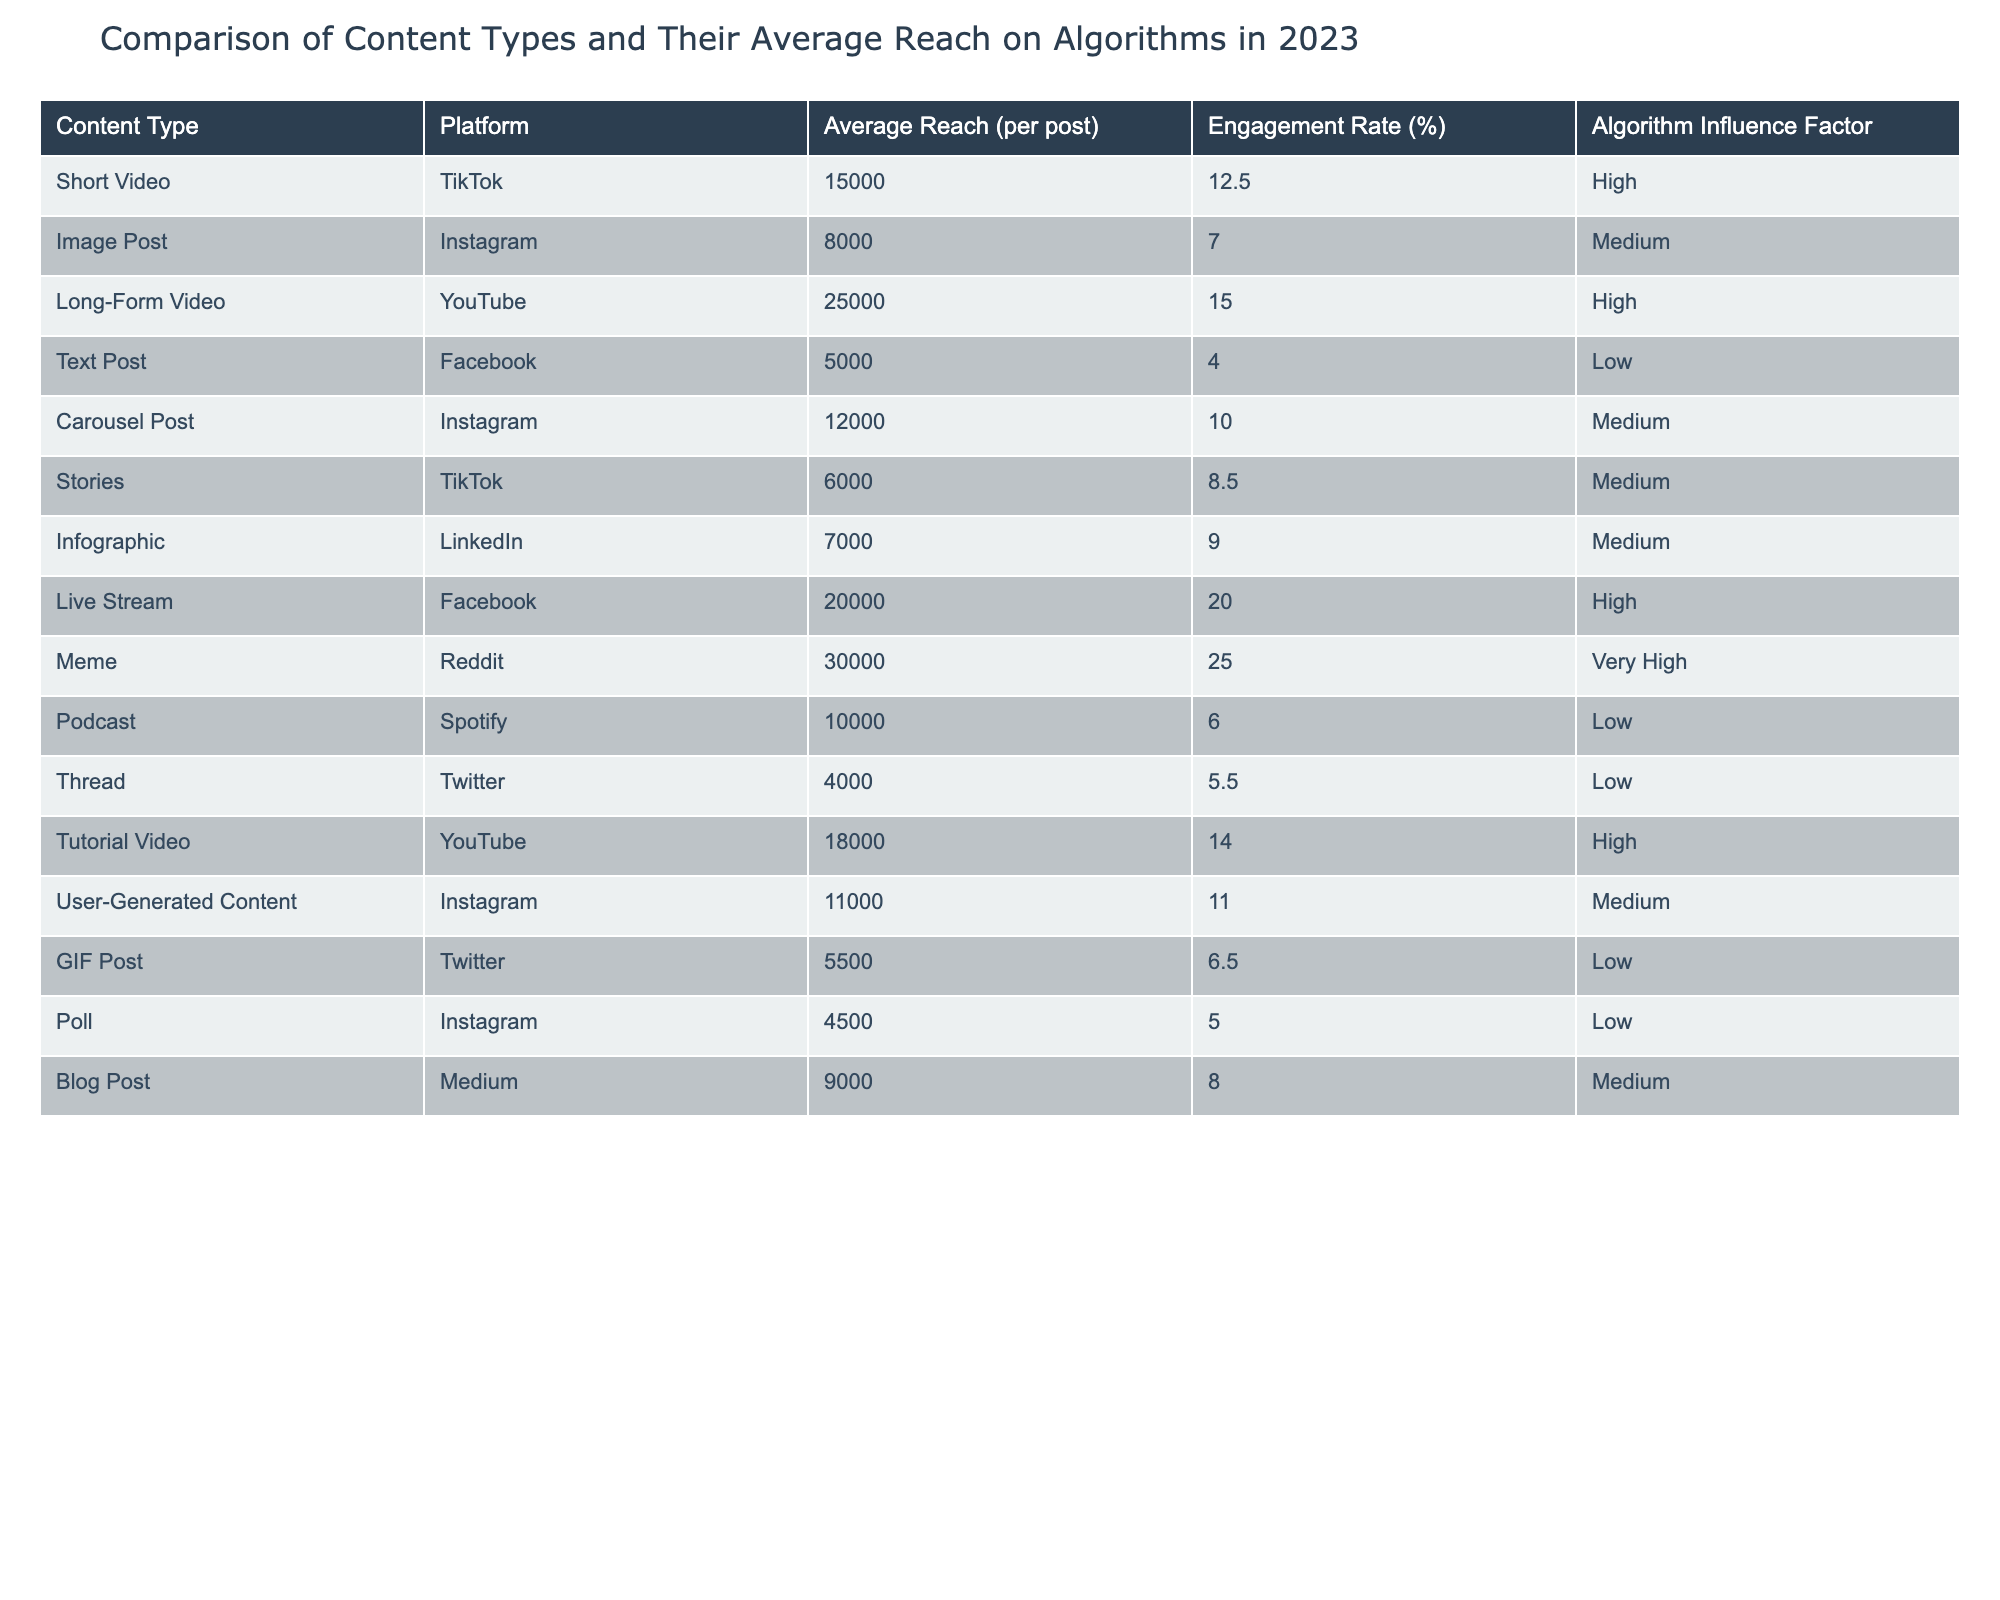What is the average reach for Long-Form Video on YouTube? The table indicates that the average reach for Long-Form Video on YouTube is 25000 per post.
Answer: 25000 Which content type has the highest engagement rate and what is that rate? In the table, the content type that has the highest engagement rate is Meme on Reddit, which has an engagement rate of 25.0%.
Answer: 25.0% How many content types have a 'Low' algorithm influence factor? By examining the table, there are four content types with a 'Low' algorithm influence factor: Text Post, Podcast, Thread, and GIF Post.
Answer: 4 What is the difference in average reach between Carousel Post and Stories on TikTok? The average reach for Carousel Post is 12000 and for Stories, it is 6000. The difference is 12000 - 6000 = 6000.
Answer: 6000 Is the average reach for Image Posts higher than for Infographics? The average reach for Image Posts is 8000 while for Infographics it is 7000. Since 8000 is greater than 7000, the statement is true.
Answer: Yes What is the combined average reach of User-Generated Content and Carousel Post? The average reach for User-Generated Content is 11000 and for Carousel Post is 12000. Adding these together gives 11000 + 12000 = 23000.
Answer: 23000 Which content type has the lowest engagement rate and what is that rate? The table shows that Text Post on Facebook has the lowest engagement rate at 4.0%.
Answer: 4.0% If you add the average reaches of the top three content types, what is the total? The top three content types based on average reach are: Meme with 30000, Long-Form Video with 25000, and Live Stream with 20000. Adding these: 30000 + 25000 + 20000 = 75000.
Answer: 75000 What content type has a medium algorithm influence factor but the highest average reach? The content type with a medium algorithm influence factor that has the highest average reach is Carousel Post on Instagram with 12000.
Answer: Carousel Post 